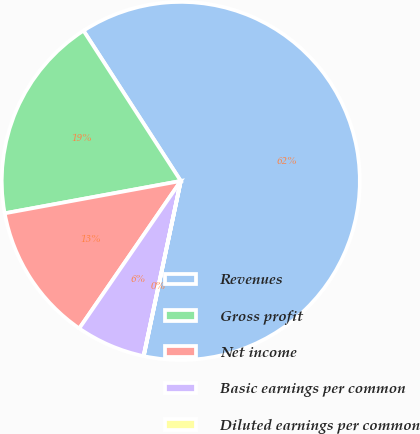<chart> <loc_0><loc_0><loc_500><loc_500><pie_chart><fcel>Revenues<fcel>Gross profit<fcel>Net income<fcel>Basic earnings per common<fcel>Diluted earnings per common<nl><fcel>62.46%<fcel>18.75%<fcel>12.51%<fcel>6.26%<fcel>0.02%<nl></chart> 